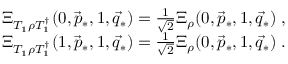<formula> <loc_0><loc_0><loc_500><loc_500>\begin{array} { r } { \Xi _ { T _ { 1 } \rho T _ { 1 } ^ { \dag } } ( 0 , \vec { p } _ { * } , 1 , \vec { q } _ { * } ) = \frac { 1 } { \sqrt { 2 } } \Xi _ { \rho } ( 0 , \vec { p } _ { * } , 1 , \vec { q } _ { * } ) \, , } \\ { \Xi _ { T _ { 1 } \rho T _ { 1 } ^ { \dag } } ( 1 , \vec { p } _ { * } , 1 , \vec { q } _ { * } ) = \frac { 1 } { \sqrt { 2 } } \Xi _ { \rho } ( 0 , \vec { p } _ { * } , 1 , \vec { q } _ { * } ) \, . } \end{array}</formula> 